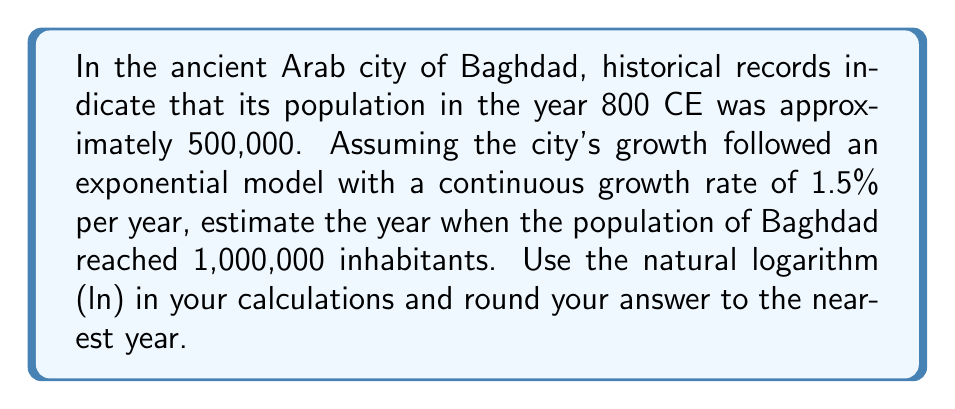Give your solution to this math problem. Let's approach this step-by-step using the exponential growth model and logarithms:

1) The exponential growth model is given by:
   $$P(t) = P_0 e^{rt}$$
   Where:
   $P(t)$ is the population at time $t$
   $P_0$ is the initial population
   $r$ is the continuous growth rate
   $t$ is the time in years

2) We know:
   $P_0 = 500,000$
   $r = 0.015$ (1.5% per year)
   $P(t) = 1,000,000$ (the population we want to reach)

3) Substituting these values into the equation:
   $$1,000,000 = 500,000 e^{0.015t}$$

4) Divide both sides by 500,000:
   $$2 = e^{0.015t}$$

5) Take the natural logarithm of both sides:
   $$\ln(2) = \ln(e^{0.015t})$$

6) Simplify the right side using the logarithm property $\ln(e^x) = x$:
   $$\ln(2) = 0.015t$$

7) Solve for $t$:
   $$t = \frac{\ln(2)}{0.015}$$

8) Calculate:
   $$t = \frac{0.693147}{0.015} \approx 46.21$$

9) Round to the nearest year:
   $t \approx 46$ years

10) Since we started at 800 CE, add 46 years to get the final year:
    800 + 46 = 846 CE
Answer: 846 CE 